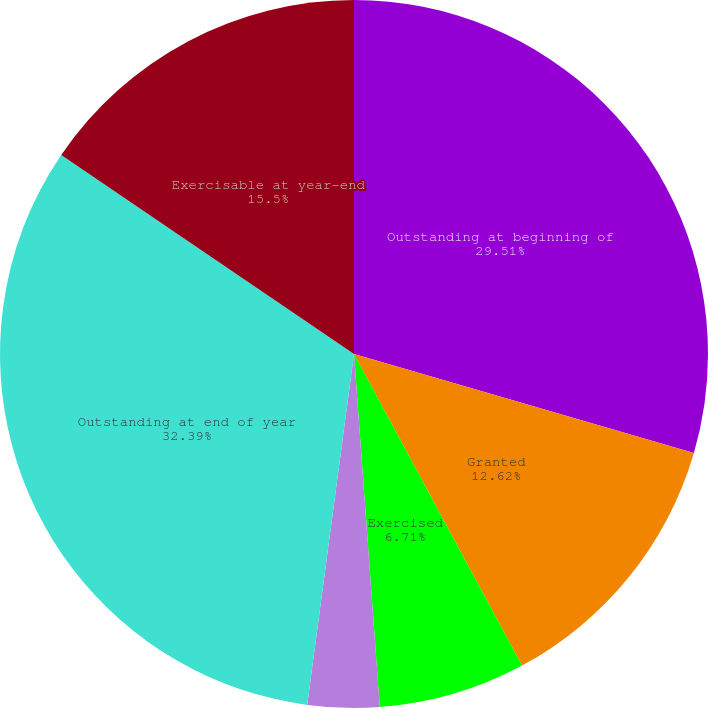Convert chart. <chart><loc_0><loc_0><loc_500><loc_500><pie_chart><fcel>Outstanding at beginning of<fcel>Granted<fcel>Exercised<fcel>Forfeited<fcel>Outstanding at end of year<fcel>Exercisable at year-end<nl><fcel>29.51%<fcel>12.62%<fcel>6.71%<fcel>3.27%<fcel>32.39%<fcel>15.5%<nl></chart> 